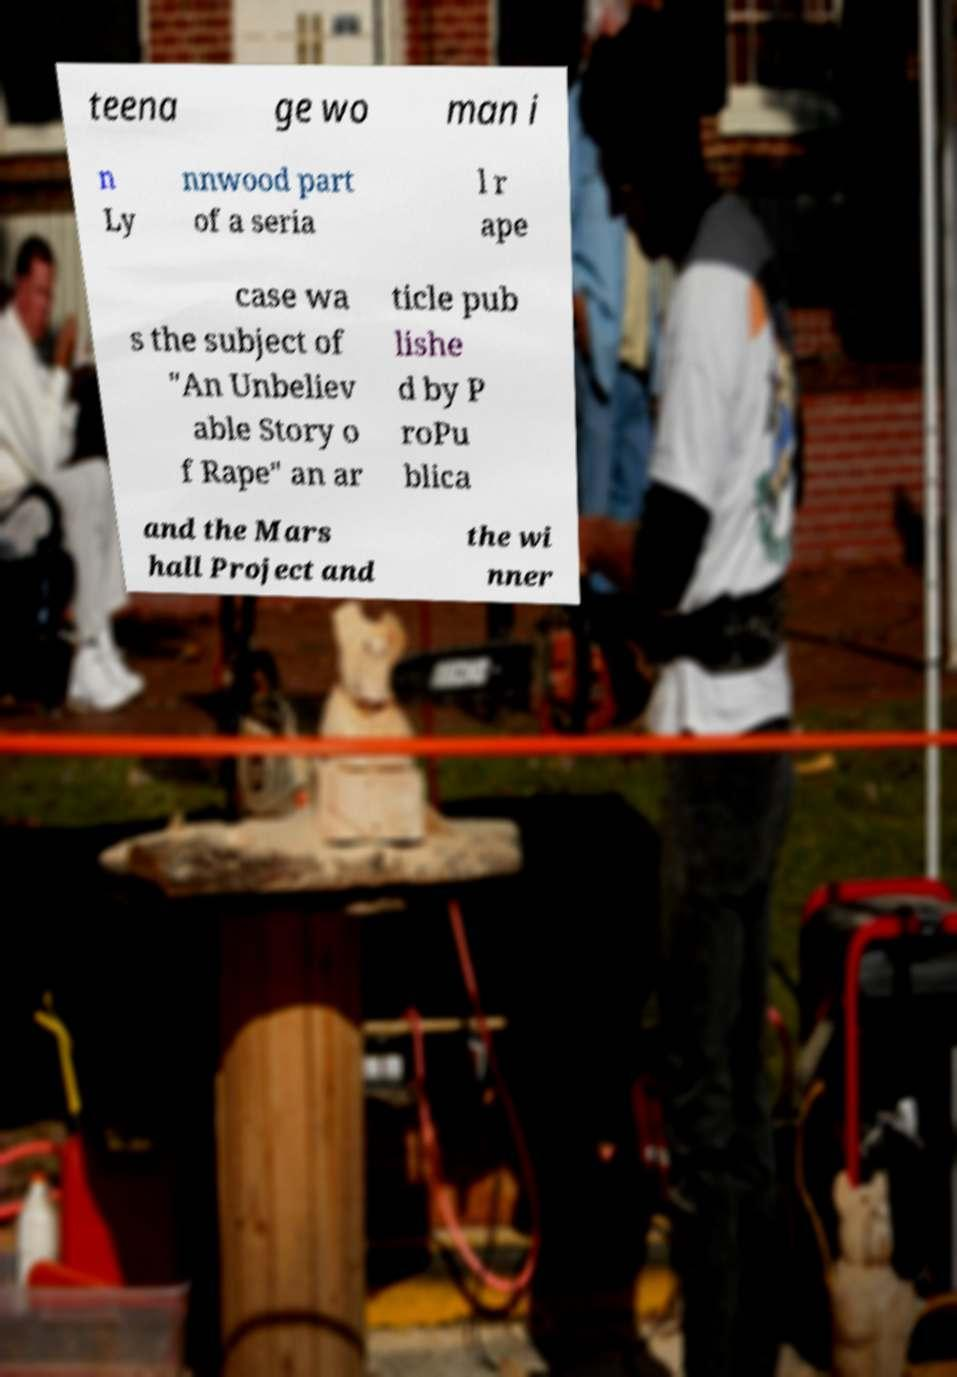Could you assist in decoding the text presented in this image and type it out clearly? teena ge wo man i n Ly nnwood part of a seria l r ape case wa s the subject of "An Unbeliev able Story o f Rape" an ar ticle pub lishe d by P roPu blica and the Mars hall Project and the wi nner 